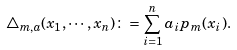Convert formula to latex. <formula><loc_0><loc_0><loc_500><loc_500>\triangle _ { m , a } ( x _ { 1 } , \cdots , x _ { n } ) \colon = \sum _ { i = 1 } ^ { n } a _ { i } p _ { m } ( x _ { i } ) .</formula> 